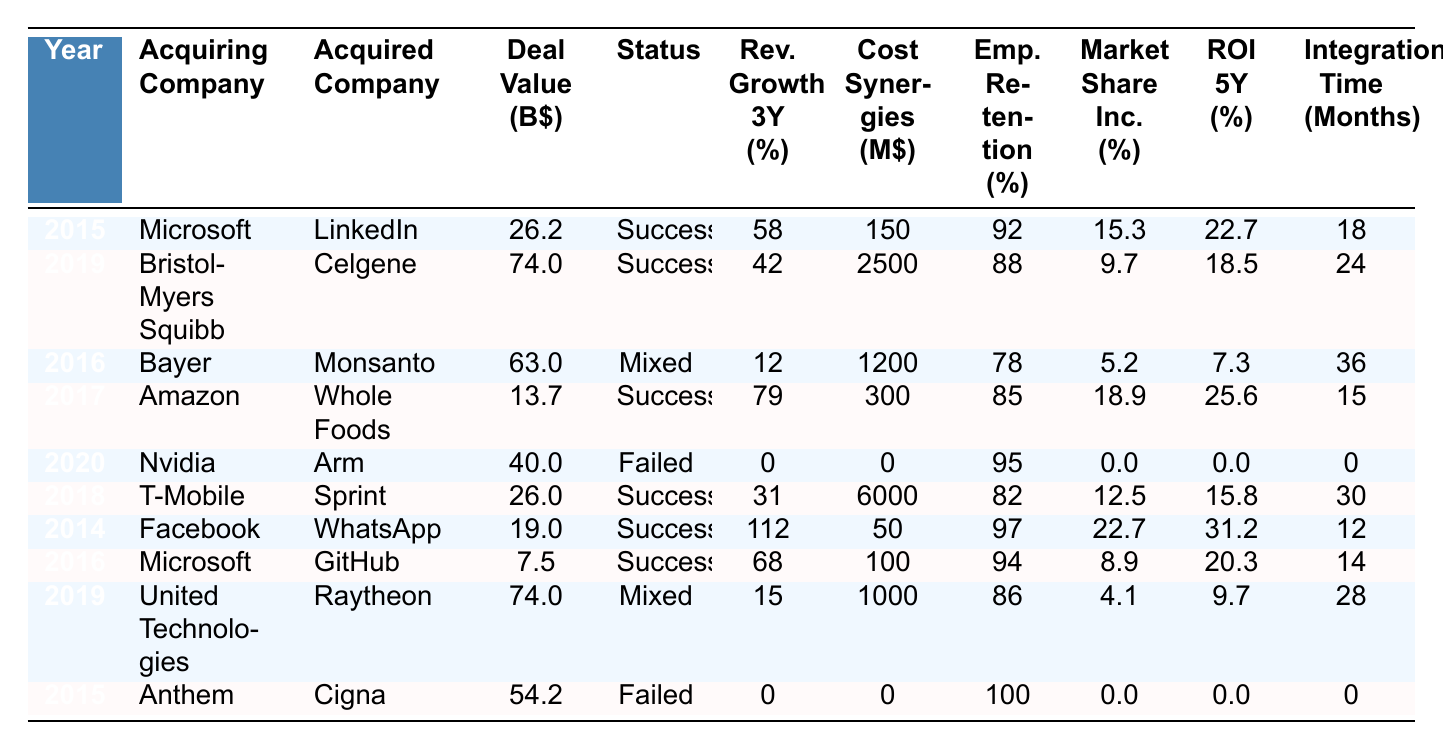What is the deal value of the merger between Microsoft and LinkedIn? You can find the deal value listed in the table under the "Deal Value (B$)" column for the row corresponding to the year 2015, where Microsoft acquired LinkedIn. The value is 26.2 billion dollars.
Answer: 26.2 billion Which acquiring company had the highest employee retention rate? By reviewing the "Emp. Retention (%)" column, the highest employee retention rate is 100%, which corresponds to the merger between Anthem and Cigna in 2015.
Answer: Anthem What is the average revenue growth over three years for the successful mergers? The successful mergers are: Microsoft-LinkedIn (58%), Bristol-Myers Squibb-Celgene (42%), Amazon-Whole Foods (79%), T-Mobile-Sprint (31%), Facebook-WhatsApp (112%), Microsoft-GitHub (68%). Summing these values gives 58 + 42 + 79 + 31 + 112 + 68 = 390. Dividing by the number of successful mergers (6), the average revenue growth is 390/6 = 65%.
Answer: 65% How many mergers had a success status of "Failed"? A scan of the "Status" column reveals there are two mergers labeled as "Failed": Nvidia-Arm in 2020 and Anthem-Cigna in 2015. Thus, there are two failed mergers.
Answer: 2 What is the difference in market share increase between the successful merger with the lowest increase and the one with the highest increase? The lowest market share increase among successful mergers is 5.2% (Bayer-Monsanto), and the highest is 112% (Facebook-WhatsApp). The difference is 112 - 5.2 = 106.8%.
Answer: 106.8% Is it true that all failed mergers had an ROI of 0%? Looking at the rows for failed mergers, both Nvidia-Arm and Anthem-Cigna have an ROI of 0% listed in the "ROI 5Y (%)" column, confirming that both failed mergers indeed had an ROI of 0%.
Answer: Yes What percent of cost synergies were achieved in the merger between T-Mobile and Sprint? The cost synergies for T-Mobile and Sprint are listed in the "Cost Synergies (M$)" column and show a value of 6000 million dollars, which was the largest among the successful mergers.
Answer: 6000 million Which acquiring company had the longest integration time? By looking at the "Integration Time (Months)" column, the merger with the longest integration time is Bayer-Monsanto, which took 36 months.
Answer: Bayer How does the average deal value of successful mergers compare to failed ones? The total deal value for successful mergers is 26.2 + 74 + 13.7 + 26 + 19 + 7.5 = 166.4 billion across five mergers, giving an average of 166.4/6 ≈ 27.73 billion. The total value for failed mergers (Nvidia-Arm: 40 billion, Anthem-Cigna: 54.2 billion) gives a total of 94.2 billion. The average for failed is 94.2/2 = 47.1 billion. Comparing these averages, successful mergers have a lower average deal value.
Answer: Successful mergers have a lower average deal value 